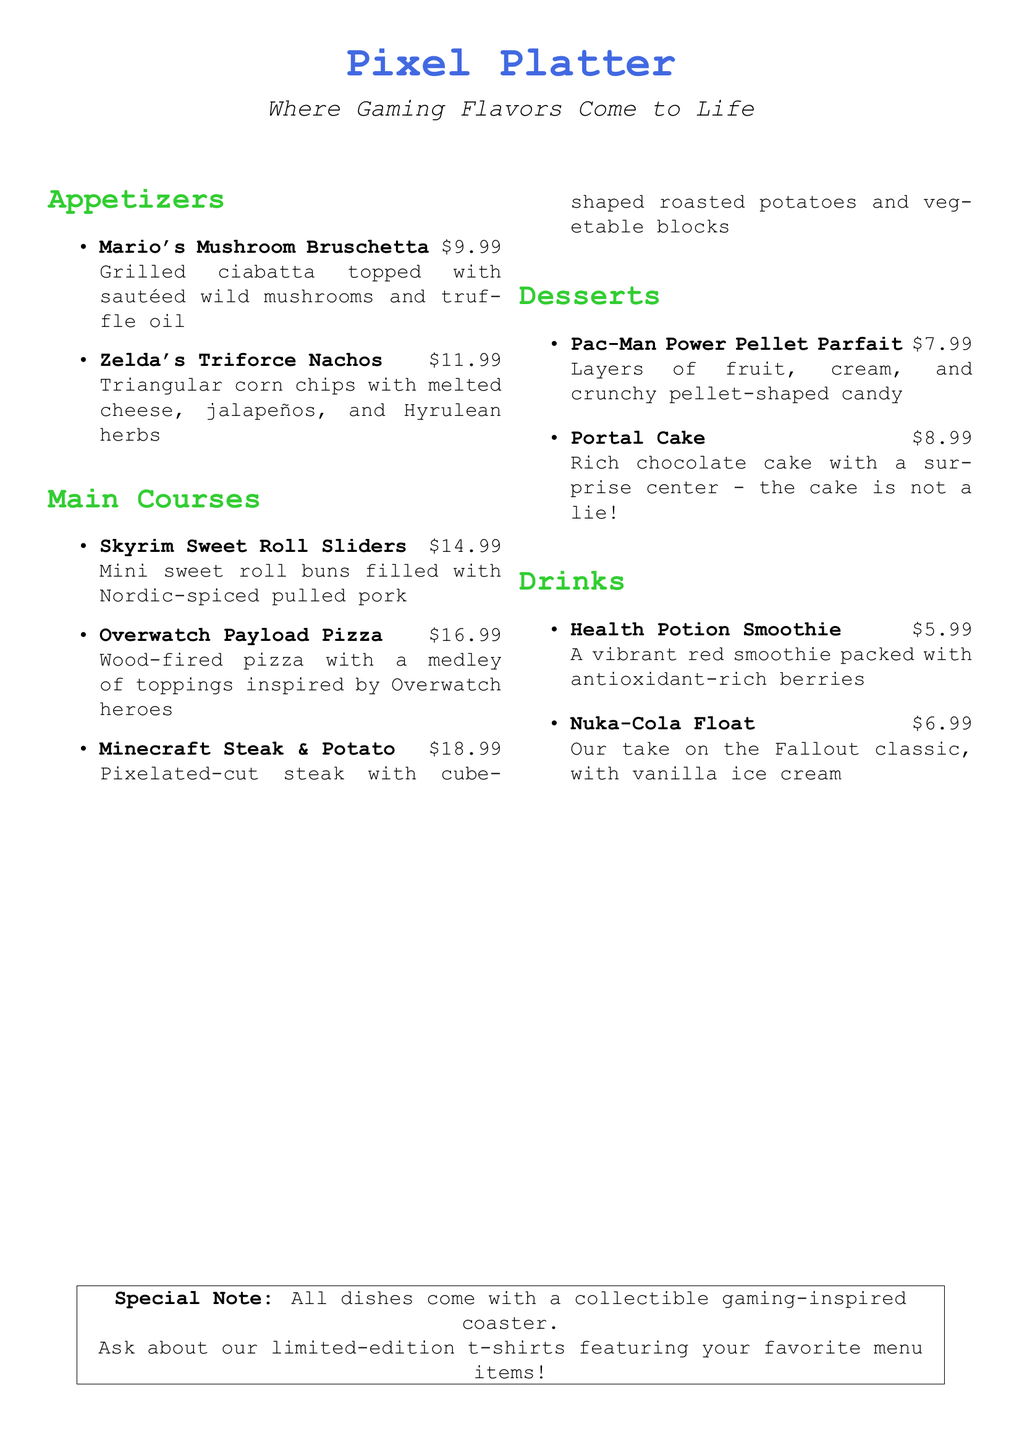What is the name of the restaurant? The name is displayed prominently at the top of the menu.
Answer: Pixel Platter How much do Zelda's Triforce Nachos cost? The price is listed next to the dish in the appetizer section.
Answer: $11.99 Which dessert features a surprise center? This information can be found in the dessert section of the menu.
Answer: Portal Cake What type of steak is served in the Minecraft dish? The specific type of steak is mentioned in the main courses section.
Answer: Pixelated-cut steak What drink is related to Fallout? The menu lists beverage options specifically themed after games, including this one.
Answer: Nuka-Cola Float How much does the Health Potion Smoothie cost? The cost is listed adjacent to the drink item in the menu.
Answer: $5.99 What special item is offered with each dish? This detail is noted at the bottom of the menu in the special note section.
Answer: Collectible gaming-inspired coaster What is the theme of the dishes? The entire menu is cohesively themed around a specific popular culture element.
Answer: Gaming franchises 